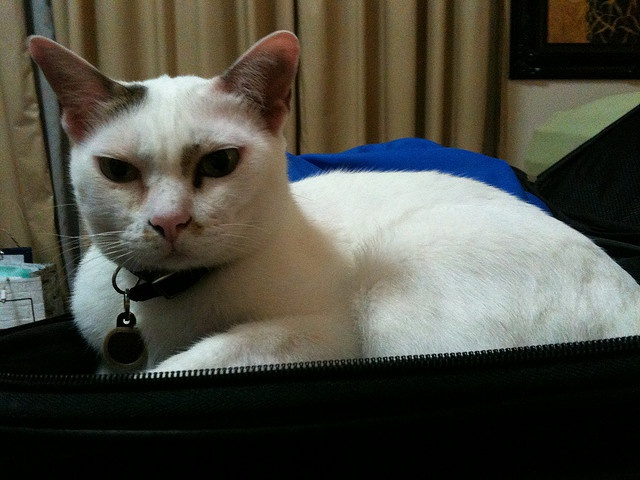Describe the objects in this image and their specific colors. I can see cat in gray, lightgray, darkgray, and black tones and suitcase in gray, black, and darkgray tones in this image. 